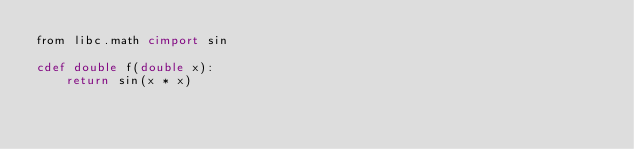<code> <loc_0><loc_0><loc_500><loc_500><_Cython_>from libc.math cimport sin

cdef double f(double x):
    return sin(x * x)
</code> 